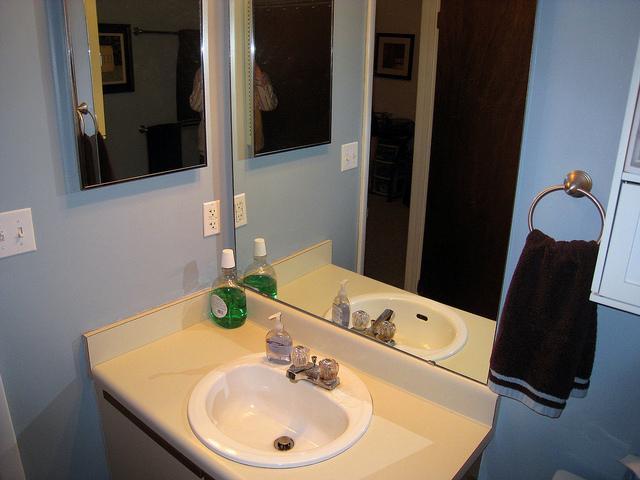How many knobs are on the faucet?
Give a very brief answer. 2. 